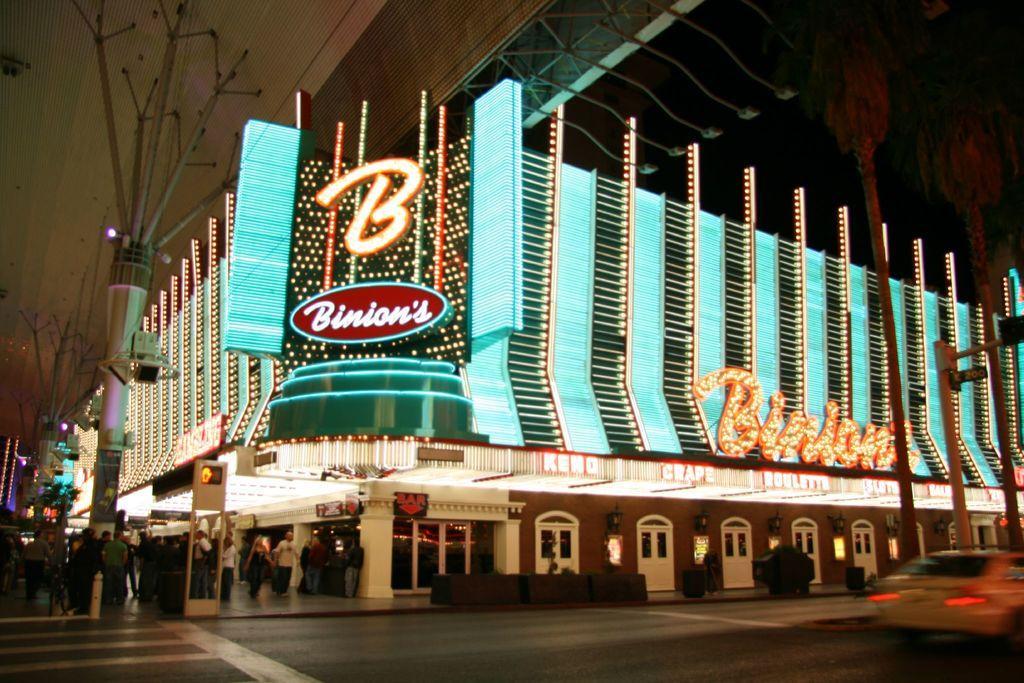In one or two sentences, can you explain what this image depicts? In this image I can see a building , in front of building there are few persons visible and there is a lighting visible on the building and in front of building there is a road, on the road there is a vehicle there is a traffic signal pole visible on the right side in front of building. 